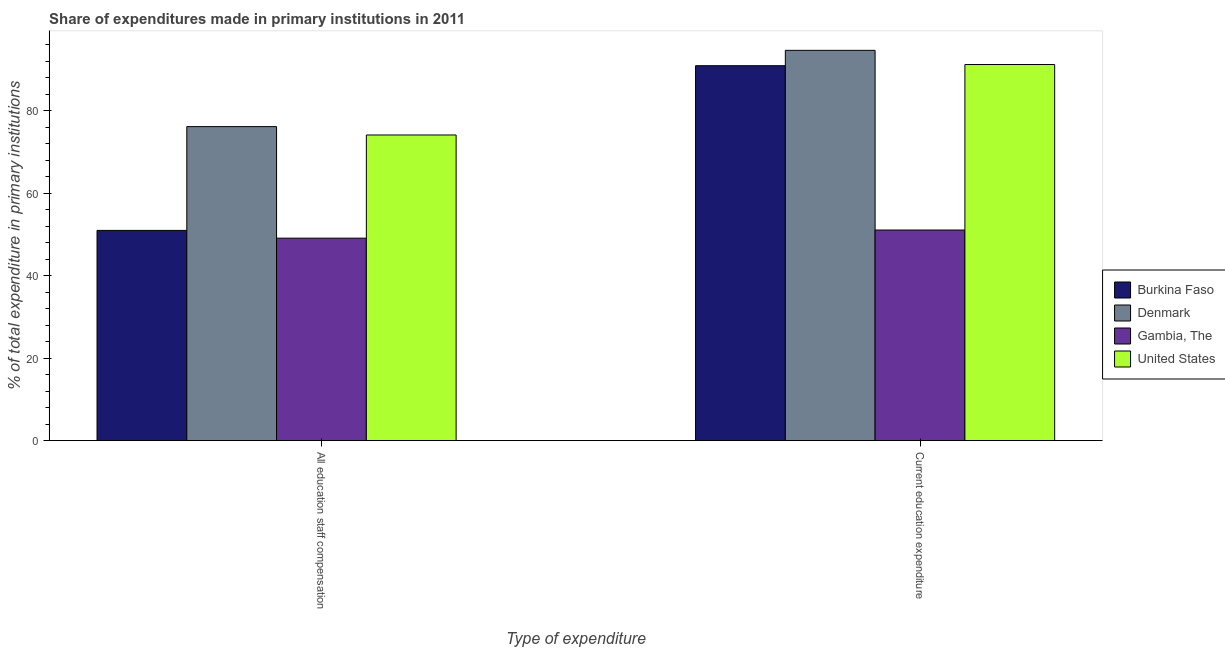How many different coloured bars are there?
Keep it short and to the point. 4. Are the number of bars on each tick of the X-axis equal?
Your answer should be compact. Yes. How many bars are there on the 2nd tick from the left?
Your answer should be compact. 4. How many bars are there on the 2nd tick from the right?
Offer a terse response. 4. What is the label of the 2nd group of bars from the left?
Keep it short and to the point. Current education expenditure. What is the expenditure in staff compensation in United States?
Your response must be concise. 74.12. Across all countries, what is the maximum expenditure in staff compensation?
Make the answer very short. 76.15. Across all countries, what is the minimum expenditure in staff compensation?
Your answer should be very brief. 49.09. In which country was the expenditure in education maximum?
Your answer should be compact. Denmark. In which country was the expenditure in education minimum?
Your answer should be compact. Gambia, The. What is the total expenditure in staff compensation in the graph?
Make the answer very short. 250.33. What is the difference between the expenditure in staff compensation in Denmark and that in Burkina Faso?
Your response must be concise. 25.17. What is the difference between the expenditure in staff compensation in Denmark and the expenditure in education in Gambia, The?
Keep it short and to the point. 25.08. What is the average expenditure in education per country?
Your answer should be compact. 81.96. What is the difference between the expenditure in staff compensation and expenditure in education in United States?
Make the answer very short. -17.09. In how many countries, is the expenditure in education greater than 72 %?
Ensure brevity in your answer.  3. What is the ratio of the expenditure in education in Burkina Faso to that in Gambia, The?
Your response must be concise. 1.78. Is the expenditure in staff compensation in Gambia, The less than that in Denmark?
Keep it short and to the point. Yes. In how many countries, is the expenditure in education greater than the average expenditure in education taken over all countries?
Provide a succinct answer. 3. What does the 2nd bar from the left in All education staff compensation represents?
Your response must be concise. Denmark. What does the 4th bar from the right in All education staff compensation represents?
Give a very brief answer. Burkina Faso. How many bars are there?
Make the answer very short. 8. Are the values on the major ticks of Y-axis written in scientific E-notation?
Keep it short and to the point. No. What is the title of the graph?
Make the answer very short. Share of expenditures made in primary institutions in 2011. What is the label or title of the X-axis?
Your answer should be very brief. Type of expenditure. What is the label or title of the Y-axis?
Give a very brief answer. % of total expenditure in primary institutions. What is the % of total expenditure in primary institutions of Burkina Faso in All education staff compensation?
Your answer should be very brief. 50.97. What is the % of total expenditure in primary institutions of Denmark in All education staff compensation?
Offer a very short reply. 76.15. What is the % of total expenditure in primary institutions in Gambia, The in All education staff compensation?
Your answer should be very brief. 49.09. What is the % of total expenditure in primary institutions of United States in All education staff compensation?
Offer a very short reply. 74.12. What is the % of total expenditure in primary institutions of Burkina Faso in Current education expenditure?
Your response must be concise. 90.92. What is the % of total expenditure in primary institutions of Denmark in Current education expenditure?
Your response must be concise. 94.65. What is the % of total expenditure in primary institutions of Gambia, The in Current education expenditure?
Your answer should be compact. 51.07. What is the % of total expenditure in primary institutions of United States in Current education expenditure?
Provide a short and direct response. 91.21. Across all Type of expenditure, what is the maximum % of total expenditure in primary institutions in Burkina Faso?
Make the answer very short. 90.92. Across all Type of expenditure, what is the maximum % of total expenditure in primary institutions in Denmark?
Make the answer very short. 94.65. Across all Type of expenditure, what is the maximum % of total expenditure in primary institutions in Gambia, The?
Provide a short and direct response. 51.07. Across all Type of expenditure, what is the maximum % of total expenditure in primary institutions in United States?
Keep it short and to the point. 91.21. Across all Type of expenditure, what is the minimum % of total expenditure in primary institutions of Burkina Faso?
Ensure brevity in your answer.  50.97. Across all Type of expenditure, what is the minimum % of total expenditure in primary institutions of Denmark?
Provide a succinct answer. 76.15. Across all Type of expenditure, what is the minimum % of total expenditure in primary institutions in Gambia, The?
Keep it short and to the point. 49.09. Across all Type of expenditure, what is the minimum % of total expenditure in primary institutions of United States?
Offer a very short reply. 74.12. What is the total % of total expenditure in primary institutions in Burkina Faso in the graph?
Offer a very short reply. 141.89. What is the total % of total expenditure in primary institutions of Denmark in the graph?
Ensure brevity in your answer.  170.79. What is the total % of total expenditure in primary institutions in Gambia, The in the graph?
Make the answer very short. 100.16. What is the total % of total expenditure in primary institutions in United States in the graph?
Provide a short and direct response. 165.32. What is the difference between the % of total expenditure in primary institutions in Burkina Faso in All education staff compensation and that in Current education expenditure?
Provide a succinct answer. -39.95. What is the difference between the % of total expenditure in primary institutions of Denmark in All education staff compensation and that in Current education expenditure?
Make the answer very short. -18.5. What is the difference between the % of total expenditure in primary institutions of Gambia, The in All education staff compensation and that in Current education expenditure?
Ensure brevity in your answer.  -1.98. What is the difference between the % of total expenditure in primary institutions in United States in All education staff compensation and that in Current education expenditure?
Ensure brevity in your answer.  -17.09. What is the difference between the % of total expenditure in primary institutions in Burkina Faso in All education staff compensation and the % of total expenditure in primary institutions in Denmark in Current education expenditure?
Ensure brevity in your answer.  -43.67. What is the difference between the % of total expenditure in primary institutions of Burkina Faso in All education staff compensation and the % of total expenditure in primary institutions of Gambia, The in Current education expenditure?
Your response must be concise. -0.09. What is the difference between the % of total expenditure in primary institutions in Burkina Faso in All education staff compensation and the % of total expenditure in primary institutions in United States in Current education expenditure?
Your answer should be very brief. -40.23. What is the difference between the % of total expenditure in primary institutions of Denmark in All education staff compensation and the % of total expenditure in primary institutions of Gambia, The in Current education expenditure?
Ensure brevity in your answer.  25.08. What is the difference between the % of total expenditure in primary institutions of Denmark in All education staff compensation and the % of total expenditure in primary institutions of United States in Current education expenditure?
Your response must be concise. -15.06. What is the difference between the % of total expenditure in primary institutions of Gambia, The in All education staff compensation and the % of total expenditure in primary institutions of United States in Current education expenditure?
Keep it short and to the point. -42.12. What is the average % of total expenditure in primary institutions in Burkina Faso per Type of expenditure?
Ensure brevity in your answer.  70.95. What is the average % of total expenditure in primary institutions of Denmark per Type of expenditure?
Offer a terse response. 85.4. What is the average % of total expenditure in primary institutions of Gambia, The per Type of expenditure?
Offer a terse response. 50.08. What is the average % of total expenditure in primary institutions in United States per Type of expenditure?
Your response must be concise. 82.66. What is the difference between the % of total expenditure in primary institutions in Burkina Faso and % of total expenditure in primary institutions in Denmark in All education staff compensation?
Your answer should be very brief. -25.17. What is the difference between the % of total expenditure in primary institutions of Burkina Faso and % of total expenditure in primary institutions of Gambia, The in All education staff compensation?
Ensure brevity in your answer.  1.88. What is the difference between the % of total expenditure in primary institutions of Burkina Faso and % of total expenditure in primary institutions of United States in All education staff compensation?
Offer a terse response. -23.14. What is the difference between the % of total expenditure in primary institutions of Denmark and % of total expenditure in primary institutions of Gambia, The in All education staff compensation?
Your answer should be compact. 27.06. What is the difference between the % of total expenditure in primary institutions in Denmark and % of total expenditure in primary institutions in United States in All education staff compensation?
Ensure brevity in your answer.  2.03. What is the difference between the % of total expenditure in primary institutions of Gambia, The and % of total expenditure in primary institutions of United States in All education staff compensation?
Provide a succinct answer. -25.03. What is the difference between the % of total expenditure in primary institutions of Burkina Faso and % of total expenditure in primary institutions of Denmark in Current education expenditure?
Ensure brevity in your answer.  -3.73. What is the difference between the % of total expenditure in primary institutions in Burkina Faso and % of total expenditure in primary institutions in Gambia, The in Current education expenditure?
Keep it short and to the point. 39.85. What is the difference between the % of total expenditure in primary institutions of Burkina Faso and % of total expenditure in primary institutions of United States in Current education expenditure?
Your response must be concise. -0.29. What is the difference between the % of total expenditure in primary institutions in Denmark and % of total expenditure in primary institutions in Gambia, The in Current education expenditure?
Provide a succinct answer. 43.58. What is the difference between the % of total expenditure in primary institutions in Denmark and % of total expenditure in primary institutions in United States in Current education expenditure?
Ensure brevity in your answer.  3.44. What is the difference between the % of total expenditure in primary institutions in Gambia, The and % of total expenditure in primary institutions in United States in Current education expenditure?
Provide a short and direct response. -40.14. What is the ratio of the % of total expenditure in primary institutions in Burkina Faso in All education staff compensation to that in Current education expenditure?
Keep it short and to the point. 0.56. What is the ratio of the % of total expenditure in primary institutions of Denmark in All education staff compensation to that in Current education expenditure?
Make the answer very short. 0.8. What is the ratio of the % of total expenditure in primary institutions of Gambia, The in All education staff compensation to that in Current education expenditure?
Make the answer very short. 0.96. What is the ratio of the % of total expenditure in primary institutions in United States in All education staff compensation to that in Current education expenditure?
Your response must be concise. 0.81. What is the difference between the highest and the second highest % of total expenditure in primary institutions of Burkina Faso?
Make the answer very short. 39.95. What is the difference between the highest and the second highest % of total expenditure in primary institutions of Denmark?
Provide a short and direct response. 18.5. What is the difference between the highest and the second highest % of total expenditure in primary institutions in Gambia, The?
Offer a very short reply. 1.98. What is the difference between the highest and the second highest % of total expenditure in primary institutions of United States?
Offer a terse response. 17.09. What is the difference between the highest and the lowest % of total expenditure in primary institutions of Burkina Faso?
Provide a succinct answer. 39.95. What is the difference between the highest and the lowest % of total expenditure in primary institutions in Denmark?
Provide a short and direct response. 18.5. What is the difference between the highest and the lowest % of total expenditure in primary institutions in Gambia, The?
Make the answer very short. 1.98. What is the difference between the highest and the lowest % of total expenditure in primary institutions of United States?
Offer a very short reply. 17.09. 